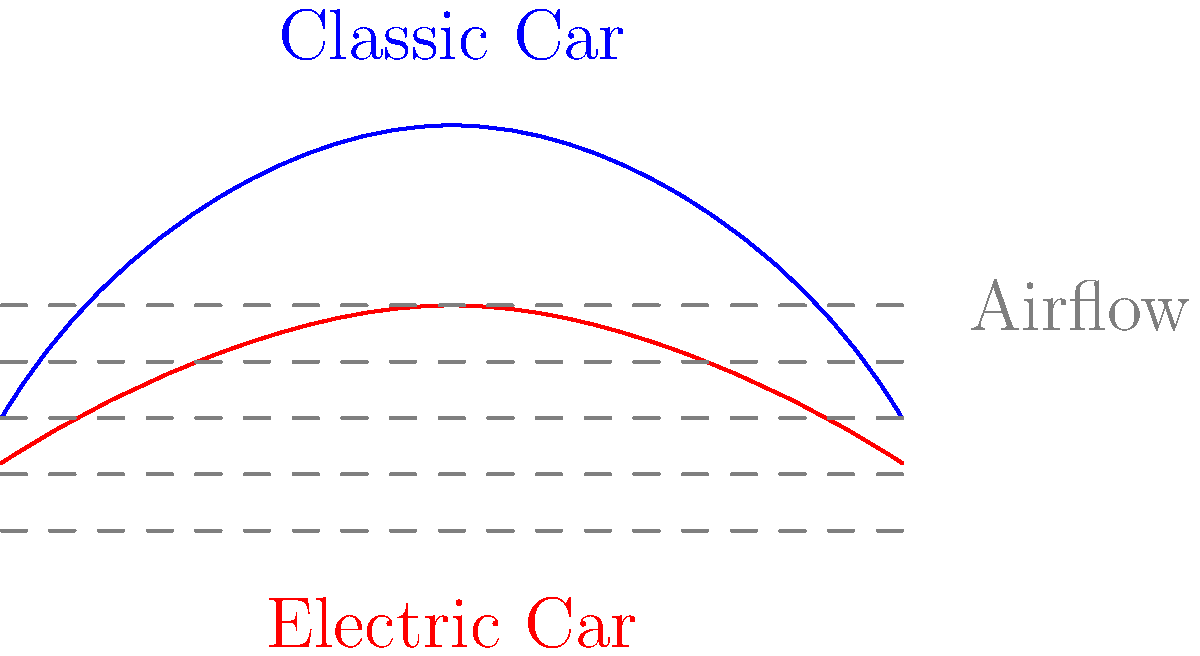Based on the airflow diagram shown, which vehicle design is likely to have a lower coefficient of drag? Explain how this affects the vehicle's performance and efficiency. To answer this question, let's analyze the diagram step-by-step:

1. Shape comparison:
   - The classic car (blue) has a more rounded, bulbous shape.
   - The electric car (red) has a lower, more streamlined profile.

2. Airflow analysis:
   - The dashed gray lines represent the airflow around the vehicles.
   - Notice how the airflow lines are more compressed and distorted around the classic car.
   - The airflow lines flow more smoothly over the electric car's profile.

3. Coefficient of drag:
   - The coefficient of drag ($$C_d$$) is a measure of a vehicle's aerodynamic efficiency.
   - Lower $$C_d$$ values indicate better aerodynamics and less air resistance.

4. Aerodynamic principles:
   - Smoother airflow generally results in lower drag.
   - Sharp changes in airflow direction increase turbulence and drag.

5. Performance implications:
   - Lower drag means less energy is required to overcome air resistance.
   - This results in better fuel efficiency or, in the case of electric vehicles, improved range.
   - At high speeds, aerodynamics become even more critical for performance.

Based on these observations, the electric car design is likely to have a lower coefficient of drag. Its streamlined shape allows air to flow more smoothly over the body, reducing turbulence and drag. This improved aerodynamics would result in better energy efficiency and potentially higher top speeds compared to the classic car design.
Answer: The electric car design has a lower coefficient of drag, improving efficiency and high-speed performance. 